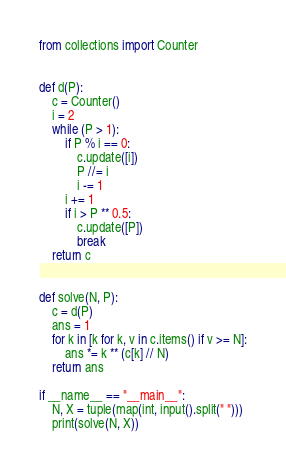<code> <loc_0><loc_0><loc_500><loc_500><_Python_>from collections import Counter


def d(P):
    c = Counter()
    i = 2
    while (P > 1):
        if P % i == 0:
            c.update([i])
            P //= i
            i -= 1
        i += 1
        if i > P ** 0.5:
            c.update([P])
            break
    return c


def solve(N, P):
    c = d(P)
    ans = 1
    for k in [k for k, v in c.items() if v >= N]:
        ans *= k ** (c[k] // N)
    return ans

if __name__ == "__main__":
    N, X = tuple(map(int, input().split(" ")))
    print(solve(N, X))
</code> 